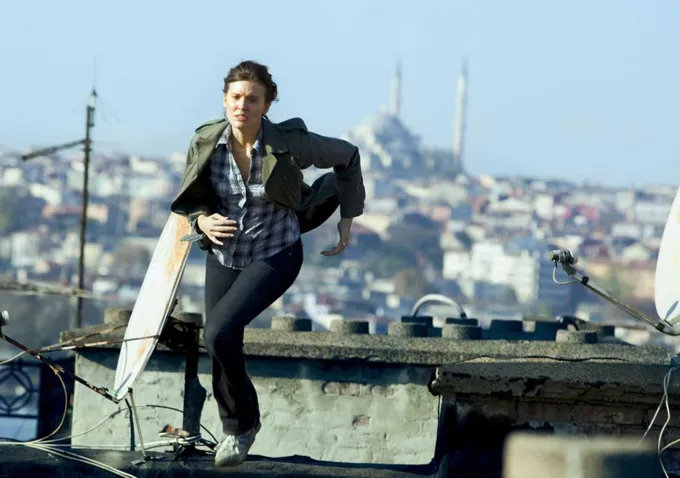What are the key elements in this picture? In the image, a person is portrayed in a dynamic moment of motion, racing across a rooftop with urgency. Their body is tilted forward, suggesting speed and purpose in their movement. The individual has a determined expression, reflecting the intensity of the moment. Loose hair blows in the breeze, which, along with the blurred backdrop, conveys a sense of swift movement. The vibrant green jacket provides a stark contrast to the neutral hues of the surrounding urban landscape. The person holds a bag, potentially an important item in the scenario depicted. Behind them is an expansive view of a city with various buildings, and a prominent hill with distinct structures crowning its summit is visible in the distance. This moment is frozen in time, encapsulating suspense and action, but the specific context remains open to interpretation. 